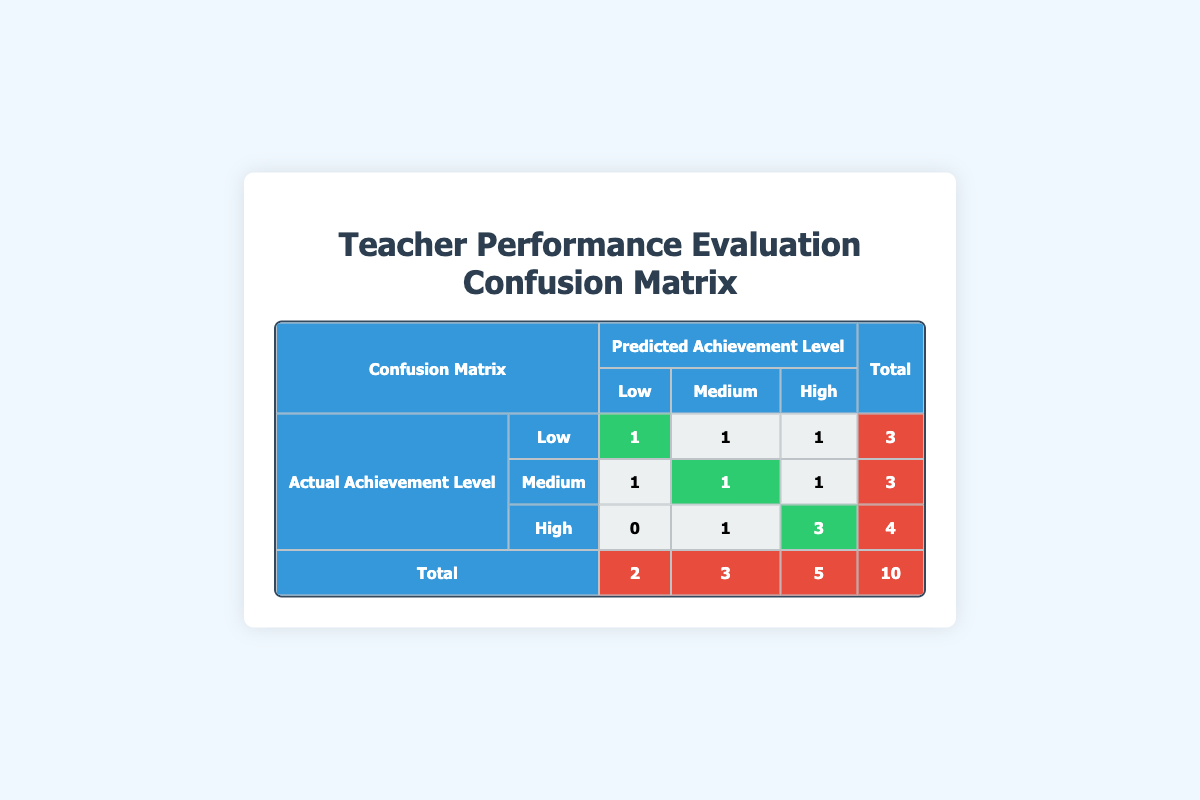What is the total number of teachers evaluated in the performance evaluation results? The total number of teachers can be found in the last row under the "Total" column, which shows 10 teachers.
Answer: 10 How many teachers were predicted to have a "High" achievement level? To find the number of teachers predicted to have a "High" achievement level, we look at the "High" column in the predicted achievement levels. The total is 5 (1 Low, 1 Medium, 3 High).
Answer: 5 How many teachers who actually achieved a "Low" level were predicted to have a "Medium" level? In the row for "Low" under "Actual Achievement Level," there is 1 teacher (Carol Lee) predicted to have a "Medium" achievement level.
Answer: 1 Were there any teachers who actually achieved a "High" level but were predicted to achieve a "Low" level? Referring to the "High" row under "Actual Achievement Level," there are no teachers predicted to have a "Low" achievement level (the count is 0).
Answer: No What percentage of teachers who actually achieved a "High" level were correctly predicted to have a "High" level? There are 4 teachers who achieved a "High" level, and 3 of them were correctly predicted as "High." To calculate the percentage, divide 3 by 4 and multiply by 100, resulting in 75%.
Answer: 75% 